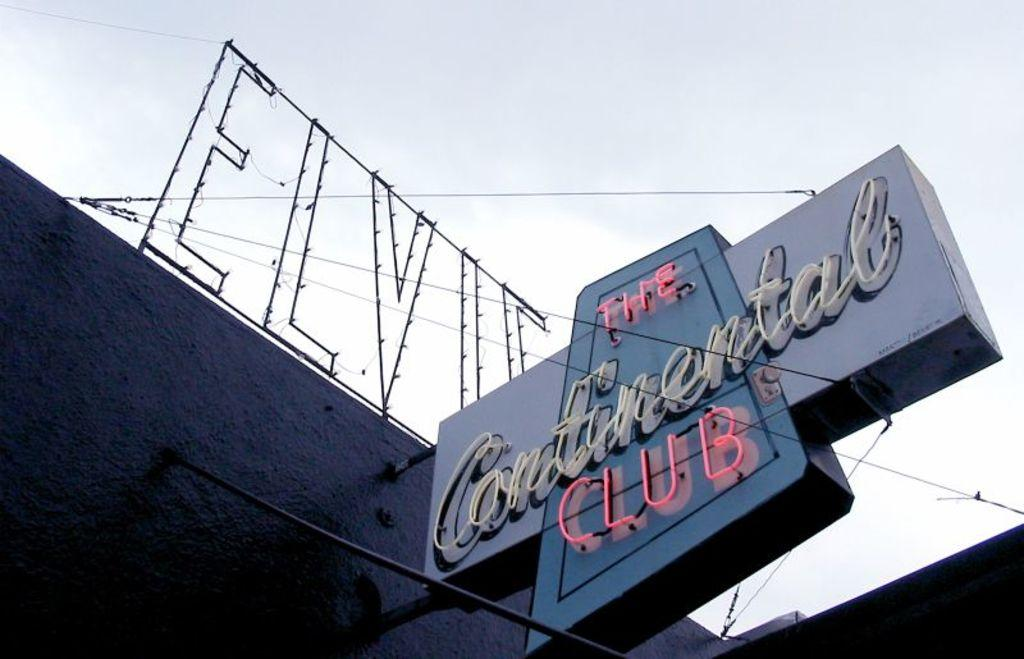Provide a one-sentence caption for the provided image. LED lights of a club named "The Continental Club". 